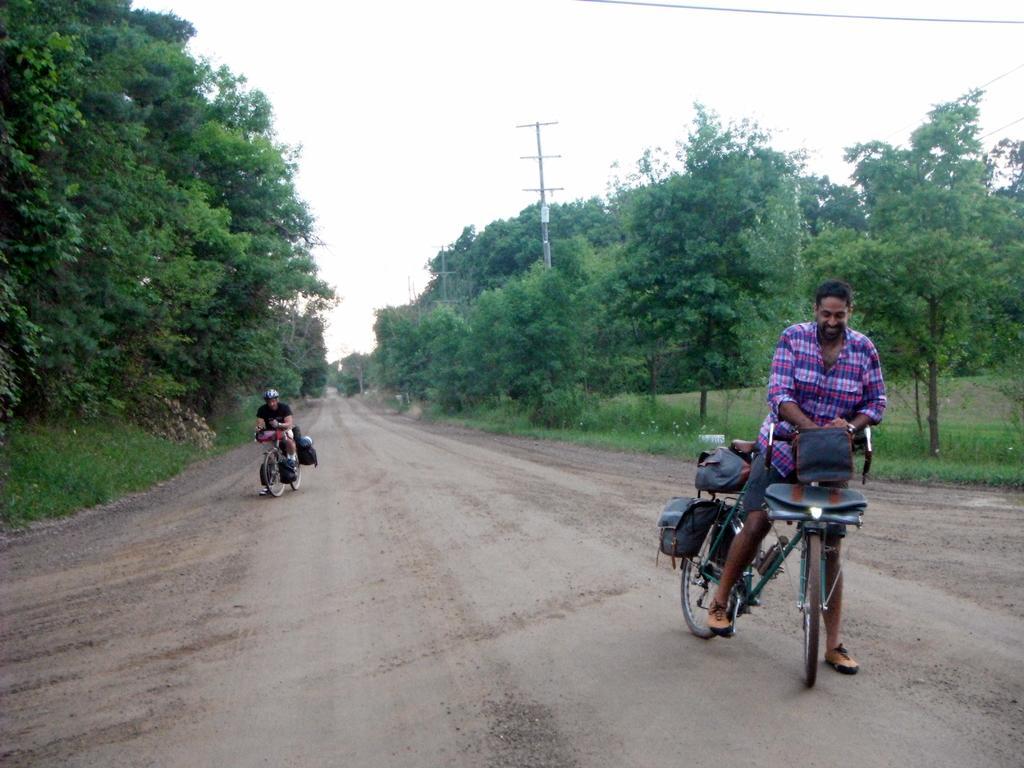In one or two sentences, can you explain what this image depicts? As we can see in the image there is a sky, trees, current pole. two people sitting on bicycles and on bicycles there are bags. 